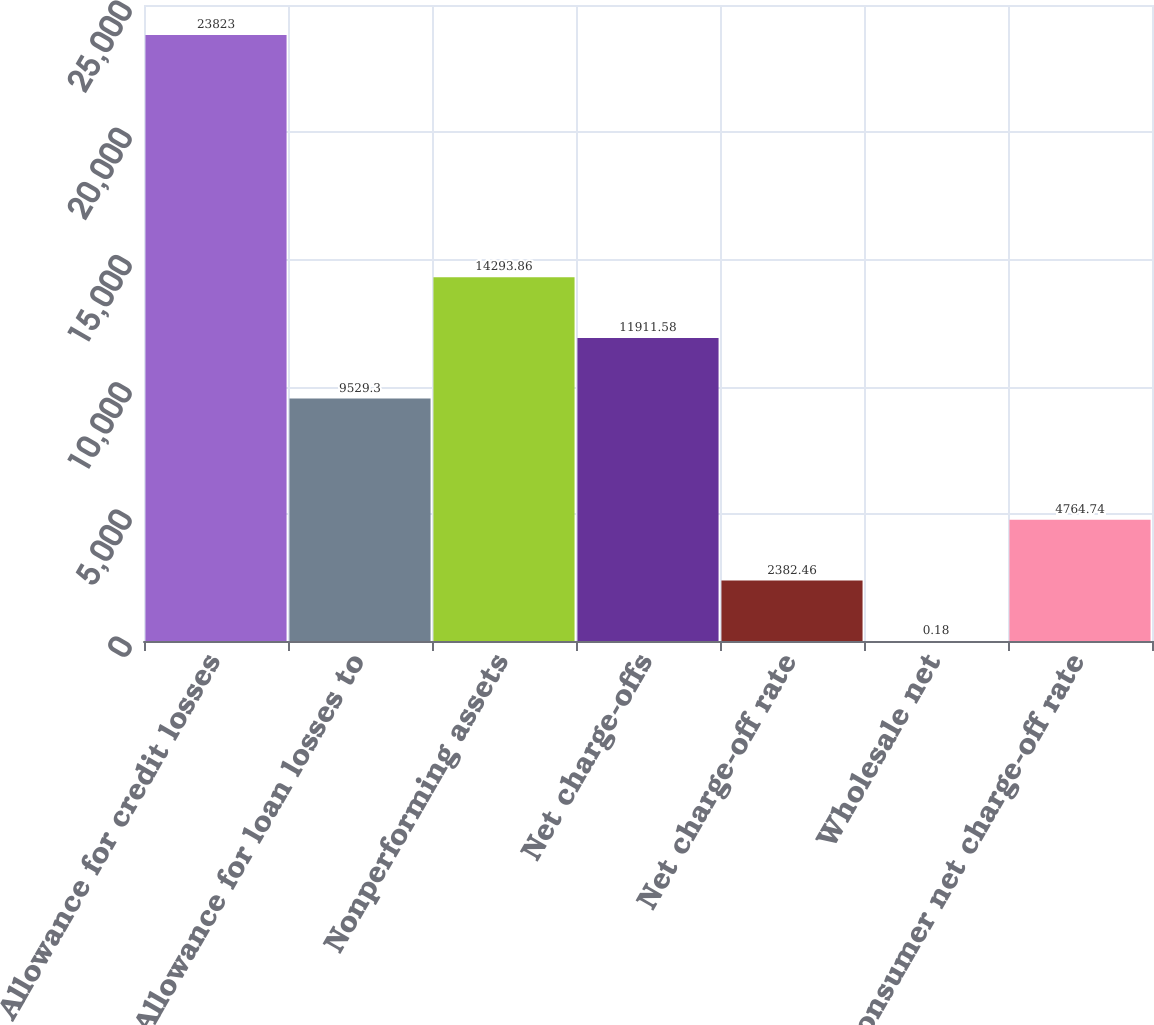Convert chart to OTSL. <chart><loc_0><loc_0><loc_500><loc_500><bar_chart><fcel>Allowance for credit losses<fcel>Allowance for loan losses to<fcel>Nonperforming assets<fcel>Net charge-offs<fcel>Net charge-off rate<fcel>Wholesale net<fcel>Consumer net charge-off rate<nl><fcel>23823<fcel>9529.3<fcel>14293.9<fcel>11911.6<fcel>2382.46<fcel>0.18<fcel>4764.74<nl></chart> 